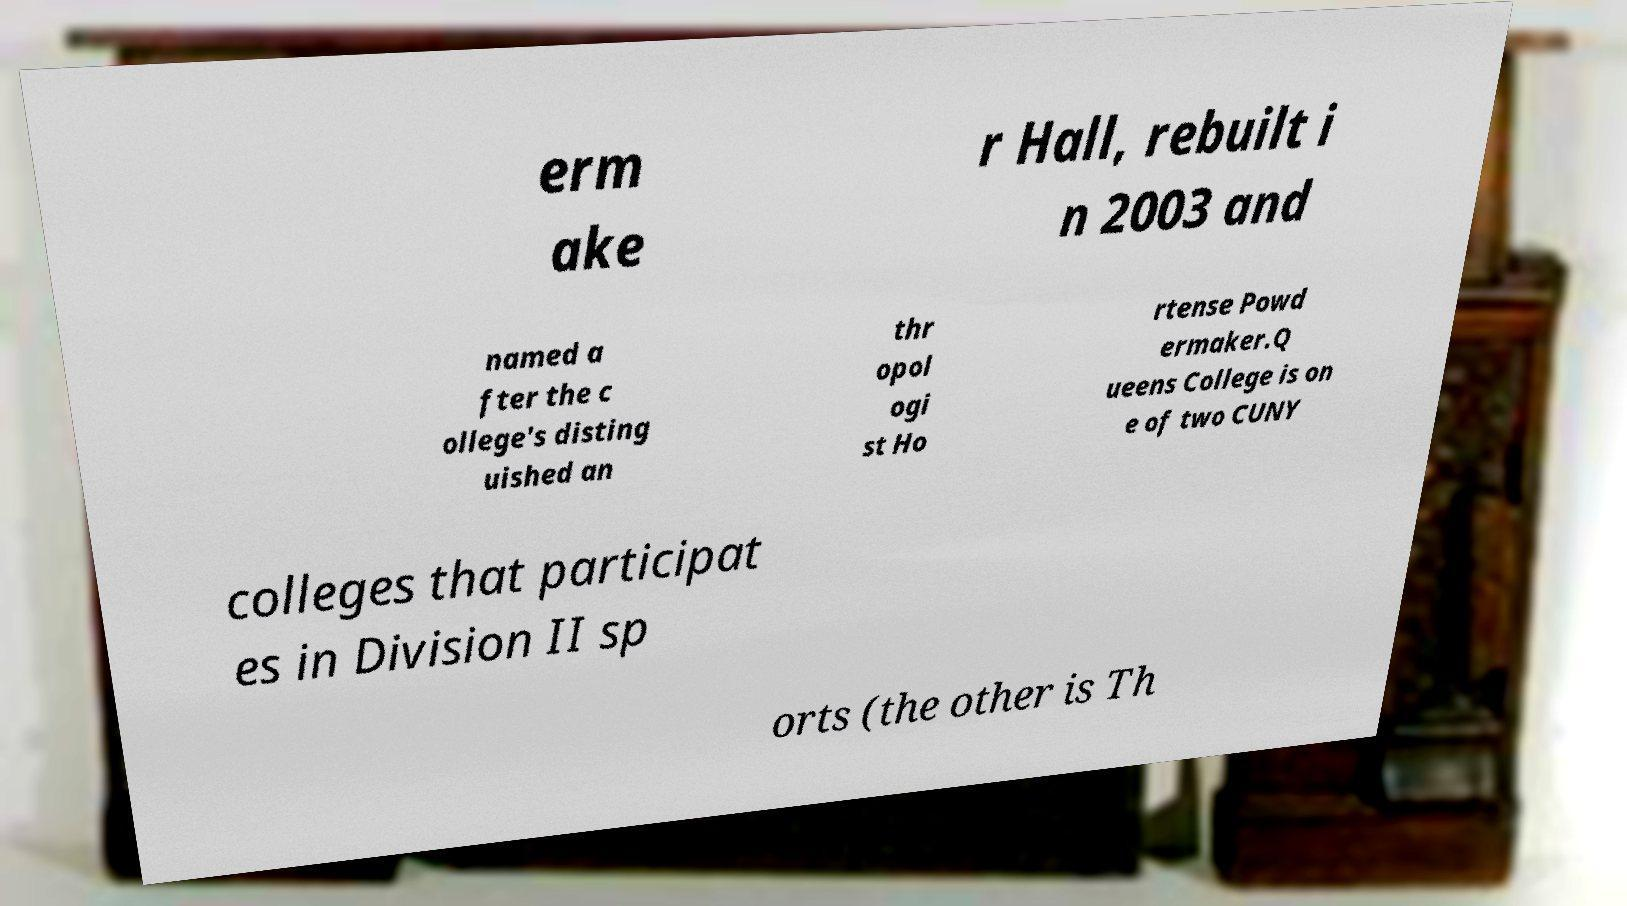There's text embedded in this image that I need extracted. Can you transcribe it verbatim? erm ake r Hall, rebuilt i n 2003 and named a fter the c ollege's disting uished an thr opol ogi st Ho rtense Powd ermaker.Q ueens College is on e of two CUNY colleges that participat es in Division II sp orts (the other is Th 